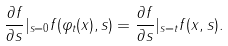<formula> <loc_0><loc_0><loc_500><loc_500>\frac { \partial f } { \partial s } | _ { s = 0 } f ( \varphi _ { t } ( x ) , s ) = \frac { \partial f } { \partial s } | _ { s = t } f ( x , s ) .</formula> 